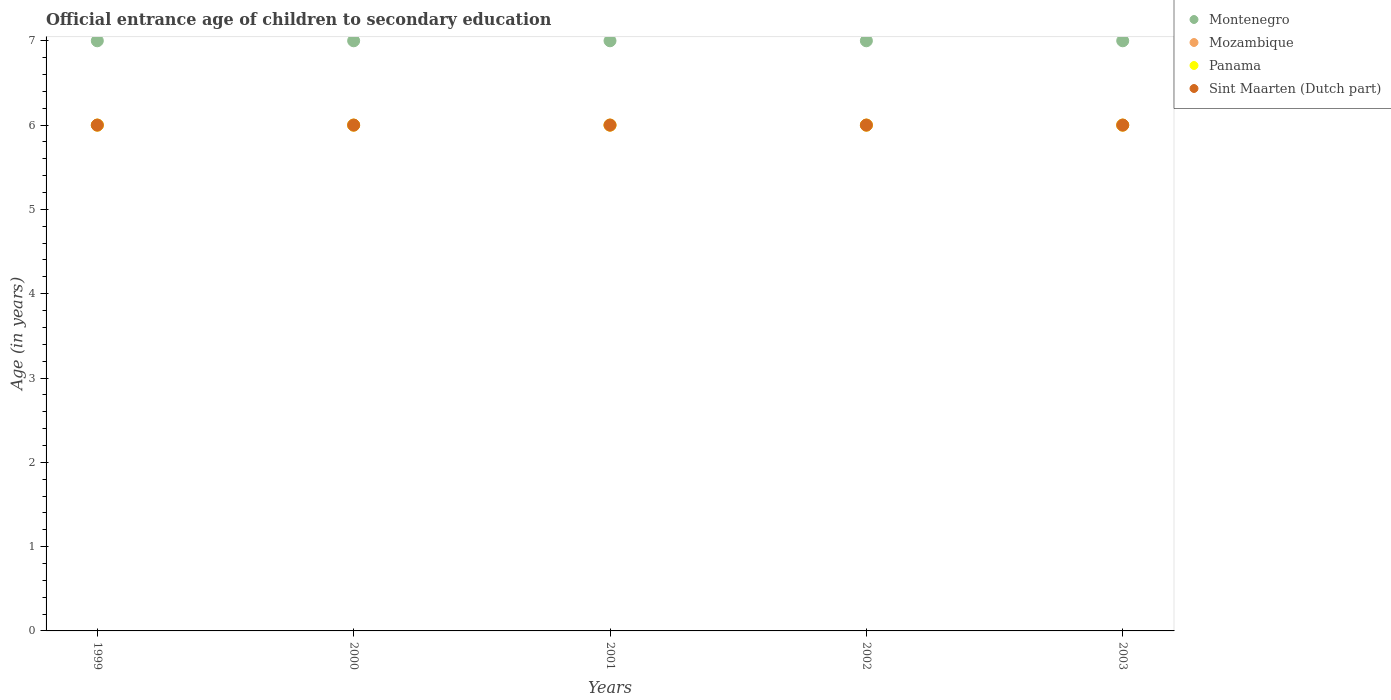How many different coloured dotlines are there?
Your response must be concise. 4. Is the number of dotlines equal to the number of legend labels?
Provide a short and direct response. Yes. What is the secondary school starting age of children in Sint Maarten (Dutch part) in 2002?
Offer a terse response. 6. Across all years, what is the maximum secondary school starting age of children in Sint Maarten (Dutch part)?
Provide a succinct answer. 6. In which year was the secondary school starting age of children in Sint Maarten (Dutch part) maximum?
Your response must be concise. 1999. In which year was the secondary school starting age of children in Montenegro minimum?
Make the answer very short. 1999. What is the total secondary school starting age of children in Panama in the graph?
Your answer should be very brief. 30. What is the difference between the secondary school starting age of children in Panama in 2000 and that in 2001?
Provide a short and direct response. 0. What is the average secondary school starting age of children in Montenegro per year?
Make the answer very short. 7. In the year 2003, what is the difference between the secondary school starting age of children in Mozambique and secondary school starting age of children in Sint Maarten (Dutch part)?
Make the answer very short. 0. Is the difference between the secondary school starting age of children in Mozambique in 1999 and 2001 greater than the difference between the secondary school starting age of children in Sint Maarten (Dutch part) in 1999 and 2001?
Ensure brevity in your answer.  No. What is the difference between the highest and the second highest secondary school starting age of children in Sint Maarten (Dutch part)?
Offer a terse response. 0. What is the difference between the highest and the lowest secondary school starting age of children in Sint Maarten (Dutch part)?
Offer a very short reply. 0. Is it the case that in every year, the sum of the secondary school starting age of children in Panama and secondary school starting age of children in Sint Maarten (Dutch part)  is greater than the secondary school starting age of children in Mozambique?
Provide a short and direct response. Yes. Is the secondary school starting age of children in Panama strictly greater than the secondary school starting age of children in Sint Maarten (Dutch part) over the years?
Provide a succinct answer. No. How many years are there in the graph?
Provide a succinct answer. 5. What is the difference between two consecutive major ticks on the Y-axis?
Your answer should be compact. 1. Does the graph contain any zero values?
Keep it short and to the point. No. Where does the legend appear in the graph?
Your answer should be compact. Top right. How are the legend labels stacked?
Ensure brevity in your answer.  Vertical. What is the title of the graph?
Ensure brevity in your answer.  Official entrance age of children to secondary education. Does "Yemen, Rep." appear as one of the legend labels in the graph?
Your answer should be compact. No. What is the label or title of the X-axis?
Make the answer very short. Years. What is the label or title of the Y-axis?
Provide a succinct answer. Age (in years). What is the Age (in years) of Montenegro in 1999?
Your answer should be very brief. 7. What is the Age (in years) of Sint Maarten (Dutch part) in 1999?
Your answer should be very brief. 6. What is the Age (in years) in Montenegro in 2000?
Give a very brief answer. 7. What is the Age (in years) in Montenegro in 2001?
Your answer should be very brief. 7. What is the Age (in years) in Mozambique in 2001?
Ensure brevity in your answer.  6. What is the Age (in years) in Mozambique in 2002?
Ensure brevity in your answer.  6. What is the Age (in years) in Panama in 2002?
Ensure brevity in your answer.  6. What is the Age (in years) of Panama in 2003?
Your response must be concise. 6. What is the Age (in years) of Sint Maarten (Dutch part) in 2003?
Your response must be concise. 6. Across all years, what is the maximum Age (in years) of Mozambique?
Your answer should be very brief. 6. Across all years, what is the maximum Age (in years) in Panama?
Provide a short and direct response. 6. Across all years, what is the maximum Age (in years) in Sint Maarten (Dutch part)?
Make the answer very short. 6. Across all years, what is the minimum Age (in years) of Montenegro?
Provide a succinct answer. 7. Across all years, what is the minimum Age (in years) in Panama?
Offer a very short reply. 6. What is the difference between the Age (in years) in Panama in 1999 and that in 2000?
Your answer should be very brief. 0. What is the difference between the Age (in years) of Mozambique in 1999 and that in 2001?
Provide a succinct answer. 0. What is the difference between the Age (in years) in Panama in 1999 and that in 2001?
Make the answer very short. 0. What is the difference between the Age (in years) of Montenegro in 1999 and that in 2002?
Provide a succinct answer. 0. What is the difference between the Age (in years) in Panama in 1999 and that in 2003?
Your answer should be very brief. 0. What is the difference between the Age (in years) of Sint Maarten (Dutch part) in 1999 and that in 2003?
Your response must be concise. 0. What is the difference between the Age (in years) of Montenegro in 2000 and that in 2001?
Make the answer very short. 0. What is the difference between the Age (in years) of Mozambique in 2000 and that in 2001?
Your answer should be very brief. 0. What is the difference between the Age (in years) of Sint Maarten (Dutch part) in 2000 and that in 2001?
Ensure brevity in your answer.  0. What is the difference between the Age (in years) of Mozambique in 2000 and that in 2002?
Make the answer very short. 0. What is the difference between the Age (in years) in Panama in 2000 and that in 2002?
Give a very brief answer. 0. What is the difference between the Age (in years) in Sint Maarten (Dutch part) in 2000 and that in 2002?
Your answer should be very brief. 0. What is the difference between the Age (in years) of Montenegro in 2000 and that in 2003?
Offer a very short reply. 0. What is the difference between the Age (in years) of Panama in 2000 and that in 2003?
Your answer should be compact. 0. What is the difference between the Age (in years) of Sint Maarten (Dutch part) in 2000 and that in 2003?
Your answer should be very brief. 0. What is the difference between the Age (in years) in Mozambique in 2001 and that in 2002?
Your response must be concise. 0. What is the difference between the Age (in years) in Panama in 2001 and that in 2002?
Provide a succinct answer. 0. What is the difference between the Age (in years) of Mozambique in 2001 and that in 2003?
Your answer should be compact. 0. What is the difference between the Age (in years) in Panama in 2001 and that in 2003?
Provide a short and direct response. 0. What is the difference between the Age (in years) of Mozambique in 2002 and that in 2003?
Your answer should be compact. 0. What is the difference between the Age (in years) in Sint Maarten (Dutch part) in 2002 and that in 2003?
Provide a succinct answer. 0. What is the difference between the Age (in years) in Montenegro in 1999 and the Age (in years) in Mozambique in 2000?
Provide a short and direct response. 1. What is the difference between the Age (in years) in Montenegro in 1999 and the Age (in years) in Panama in 2000?
Your answer should be very brief. 1. What is the difference between the Age (in years) of Mozambique in 1999 and the Age (in years) of Panama in 2001?
Ensure brevity in your answer.  0. What is the difference between the Age (in years) in Panama in 1999 and the Age (in years) in Sint Maarten (Dutch part) in 2001?
Make the answer very short. 0. What is the difference between the Age (in years) in Panama in 1999 and the Age (in years) in Sint Maarten (Dutch part) in 2002?
Make the answer very short. 0. What is the difference between the Age (in years) of Montenegro in 1999 and the Age (in years) of Mozambique in 2003?
Offer a very short reply. 1. What is the difference between the Age (in years) in Montenegro in 2000 and the Age (in years) in Panama in 2001?
Give a very brief answer. 1. What is the difference between the Age (in years) of Mozambique in 2000 and the Age (in years) of Panama in 2001?
Your answer should be very brief. 0. What is the difference between the Age (in years) of Panama in 2000 and the Age (in years) of Sint Maarten (Dutch part) in 2001?
Offer a terse response. 0. What is the difference between the Age (in years) in Montenegro in 2000 and the Age (in years) in Panama in 2002?
Make the answer very short. 1. What is the difference between the Age (in years) of Montenegro in 2000 and the Age (in years) of Sint Maarten (Dutch part) in 2002?
Give a very brief answer. 1. What is the difference between the Age (in years) of Mozambique in 2000 and the Age (in years) of Panama in 2002?
Keep it short and to the point. 0. What is the difference between the Age (in years) of Mozambique in 2000 and the Age (in years) of Sint Maarten (Dutch part) in 2002?
Your answer should be compact. 0. What is the difference between the Age (in years) of Montenegro in 2000 and the Age (in years) of Panama in 2003?
Make the answer very short. 1. What is the difference between the Age (in years) of Montenegro in 2000 and the Age (in years) of Sint Maarten (Dutch part) in 2003?
Your answer should be compact. 1. What is the difference between the Age (in years) of Mozambique in 2000 and the Age (in years) of Sint Maarten (Dutch part) in 2003?
Provide a short and direct response. 0. What is the difference between the Age (in years) in Montenegro in 2001 and the Age (in years) in Mozambique in 2002?
Keep it short and to the point. 1. What is the difference between the Age (in years) in Panama in 2001 and the Age (in years) in Sint Maarten (Dutch part) in 2002?
Provide a short and direct response. 0. What is the difference between the Age (in years) in Montenegro in 2001 and the Age (in years) in Sint Maarten (Dutch part) in 2003?
Provide a succinct answer. 1. What is the difference between the Age (in years) of Mozambique in 2001 and the Age (in years) of Panama in 2003?
Your response must be concise. 0. What is the difference between the Age (in years) of Panama in 2001 and the Age (in years) of Sint Maarten (Dutch part) in 2003?
Keep it short and to the point. 0. What is the difference between the Age (in years) of Montenegro in 2002 and the Age (in years) of Panama in 2003?
Your answer should be compact. 1. What is the difference between the Age (in years) in Montenegro in 2002 and the Age (in years) in Sint Maarten (Dutch part) in 2003?
Make the answer very short. 1. What is the difference between the Age (in years) of Panama in 2002 and the Age (in years) of Sint Maarten (Dutch part) in 2003?
Your answer should be compact. 0. What is the average Age (in years) of Montenegro per year?
Provide a short and direct response. 7. What is the average Age (in years) of Sint Maarten (Dutch part) per year?
Give a very brief answer. 6. In the year 1999, what is the difference between the Age (in years) in Montenegro and Age (in years) in Mozambique?
Ensure brevity in your answer.  1. In the year 1999, what is the difference between the Age (in years) of Montenegro and Age (in years) of Panama?
Provide a short and direct response. 1. In the year 1999, what is the difference between the Age (in years) of Montenegro and Age (in years) of Sint Maarten (Dutch part)?
Ensure brevity in your answer.  1. In the year 1999, what is the difference between the Age (in years) of Mozambique and Age (in years) of Sint Maarten (Dutch part)?
Give a very brief answer. 0. In the year 1999, what is the difference between the Age (in years) in Panama and Age (in years) in Sint Maarten (Dutch part)?
Give a very brief answer. 0. In the year 2000, what is the difference between the Age (in years) in Montenegro and Age (in years) in Panama?
Keep it short and to the point. 1. In the year 2000, what is the difference between the Age (in years) of Panama and Age (in years) of Sint Maarten (Dutch part)?
Ensure brevity in your answer.  0. In the year 2001, what is the difference between the Age (in years) of Montenegro and Age (in years) of Mozambique?
Keep it short and to the point. 1. In the year 2001, what is the difference between the Age (in years) of Montenegro and Age (in years) of Sint Maarten (Dutch part)?
Ensure brevity in your answer.  1. In the year 2001, what is the difference between the Age (in years) in Mozambique and Age (in years) in Sint Maarten (Dutch part)?
Ensure brevity in your answer.  0. In the year 2002, what is the difference between the Age (in years) of Montenegro and Age (in years) of Panama?
Your response must be concise. 1. In the year 2002, what is the difference between the Age (in years) of Mozambique and Age (in years) of Sint Maarten (Dutch part)?
Give a very brief answer. 0. In the year 2003, what is the difference between the Age (in years) in Montenegro and Age (in years) in Sint Maarten (Dutch part)?
Your answer should be compact. 1. In the year 2003, what is the difference between the Age (in years) in Panama and Age (in years) in Sint Maarten (Dutch part)?
Your answer should be very brief. 0. What is the ratio of the Age (in years) in Mozambique in 1999 to that in 2000?
Give a very brief answer. 1. What is the ratio of the Age (in years) of Sint Maarten (Dutch part) in 1999 to that in 2000?
Offer a terse response. 1. What is the ratio of the Age (in years) in Montenegro in 1999 to that in 2001?
Offer a terse response. 1. What is the ratio of the Age (in years) of Mozambique in 1999 to that in 2001?
Offer a very short reply. 1. What is the ratio of the Age (in years) of Panama in 1999 to that in 2001?
Your response must be concise. 1. What is the ratio of the Age (in years) in Sint Maarten (Dutch part) in 1999 to that in 2001?
Make the answer very short. 1. What is the ratio of the Age (in years) in Montenegro in 1999 to that in 2002?
Offer a terse response. 1. What is the ratio of the Age (in years) in Mozambique in 1999 to that in 2002?
Your answer should be very brief. 1. What is the ratio of the Age (in years) in Panama in 1999 to that in 2002?
Your response must be concise. 1. What is the ratio of the Age (in years) of Sint Maarten (Dutch part) in 1999 to that in 2002?
Offer a very short reply. 1. What is the ratio of the Age (in years) in Sint Maarten (Dutch part) in 1999 to that in 2003?
Provide a short and direct response. 1. What is the ratio of the Age (in years) of Montenegro in 2000 to that in 2001?
Provide a succinct answer. 1. What is the ratio of the Age (in years) in Panama in 2000 to that in 2001?
Provide a short and direct response. 1. What is the ratio of the Age (in years) in Sint Maarten (Dutch part) in 2000 to that in 2001?
Provide a short and direct response. 1. What is the ratio of the Age (in years) of Montenegro in 2000 to that in 2003?
Provide a succinct answer. 1. What is the ratio of the Age (in years) in Sint Maarten (Dutch part) in 2000 to that in 2003?
Provide a succinct answer. 1. What is the ratio of the Age (in years) in Panama in 2001 to that in 2002?
Offer a terse response. 1. What is the ratio of the Age (in years) of Sint Maarten (Dutch part) in 2001 to that in 2002?
Offer a very short reply. 1. What is the ratio of the Age (in years) in Panama in 2001 to that in 2003?
Provide a succinct answer. 1. What is the ratio of the Age (in years) of Montenegro in 2002 to that in 2003?
Offer a very short reply. 1. What is the ratio of the Age (in years) in Mozambique in 2002 to that in 2003?
Your answer should be compact. 1. What is the ratio of the Age (in years) in Panama in 2002 to that in 2003?
Ensure brevity in your answer.  1. What is the difference between the highest and the second highest Age (in years) of Sint Maarten (Dutch part)?
Ensure brevity in your answer.  0. What is the difference between the highest and the lowest Age (in years) in Panama?
Provide a succinct answer. 0. 